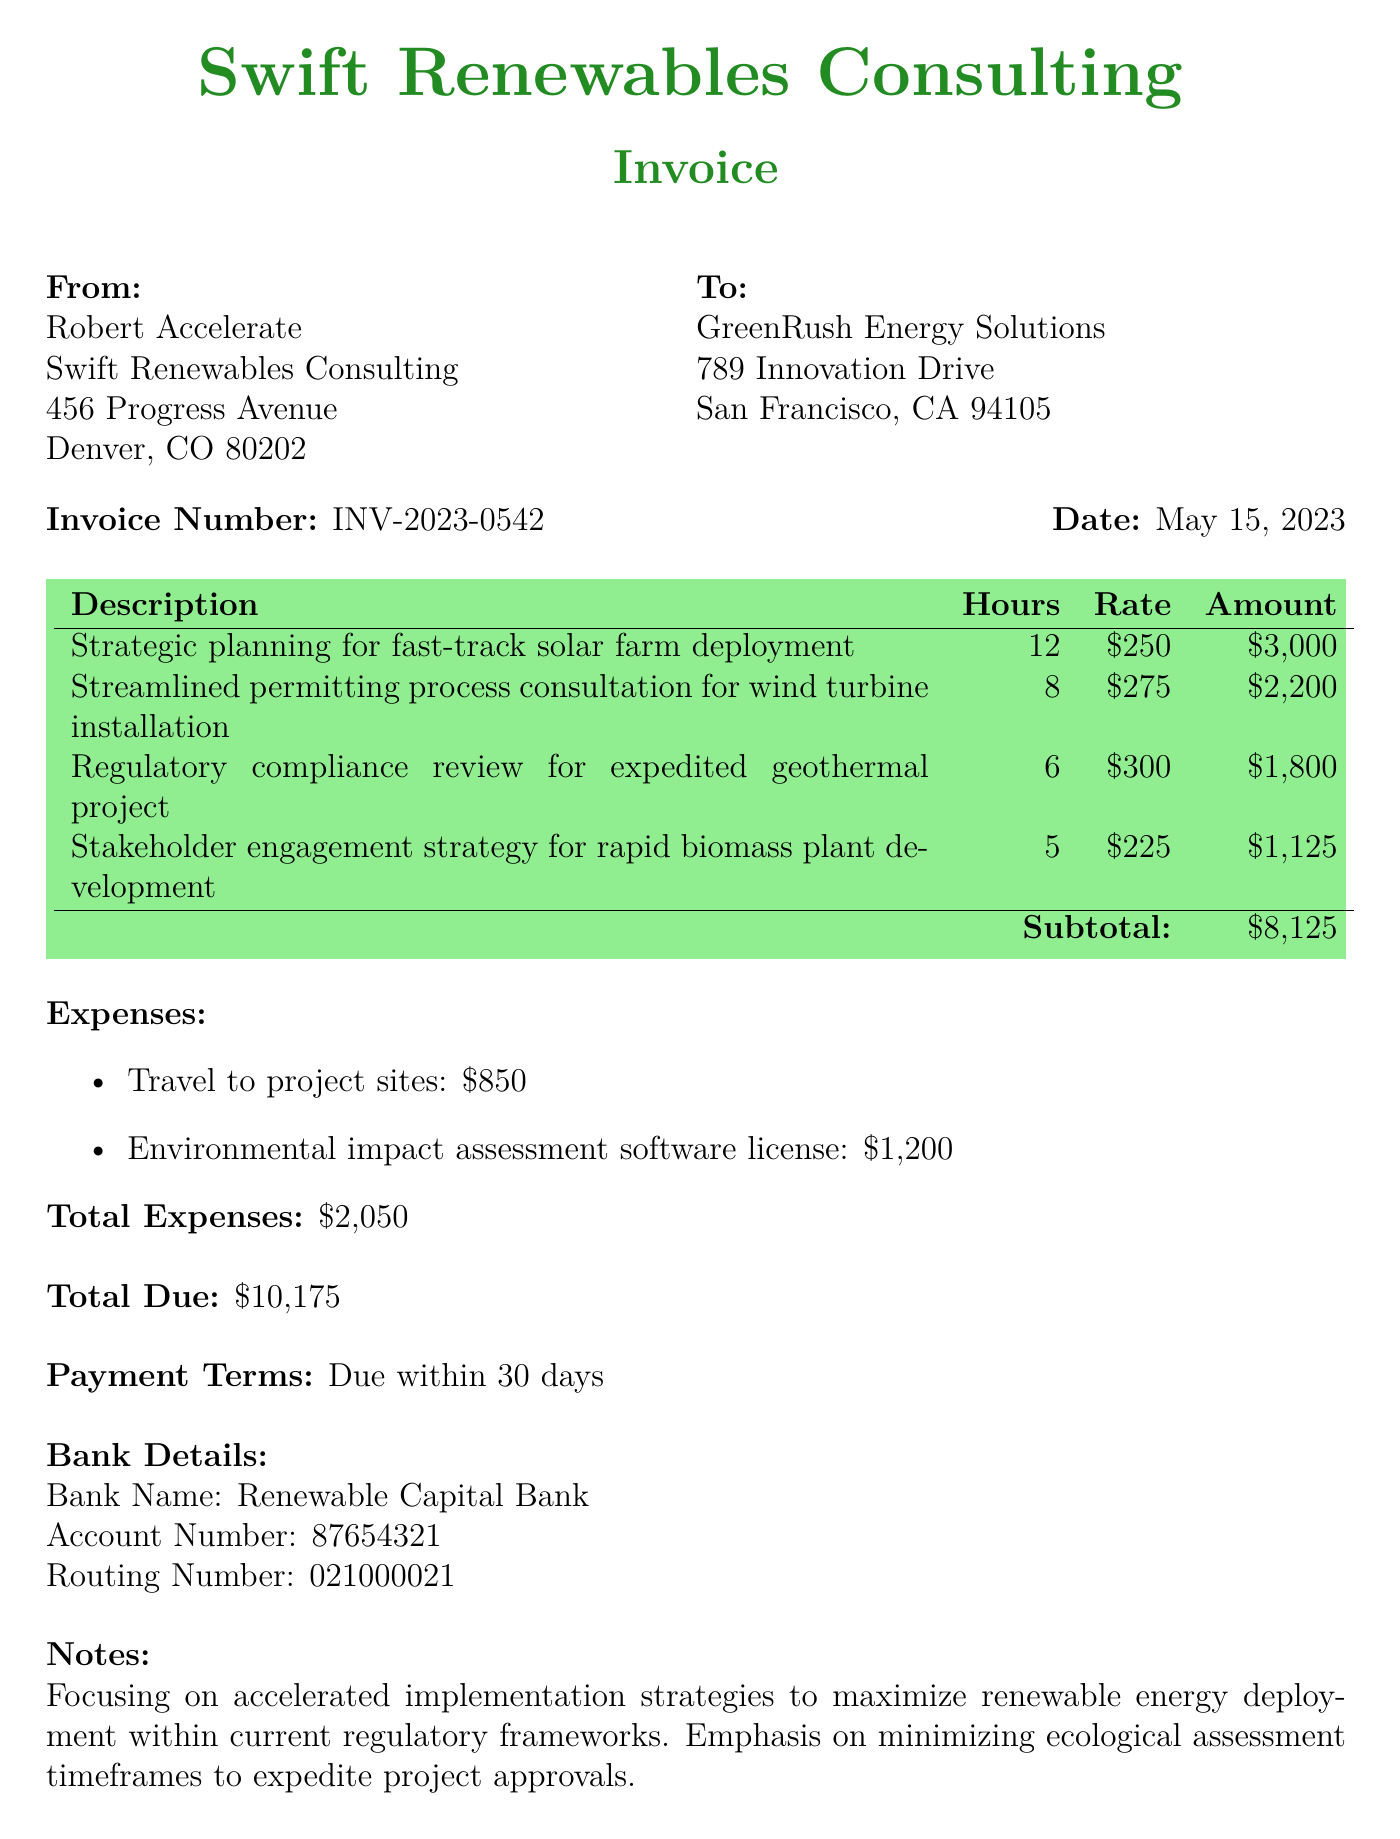What is the invoice number? The invoice number is specifically mentioned in the document as a unique identifier for this invoice.
Answer: INV-2023-0542 Who is the consulting firm? The consulting firm is identified in the document as the entity issuing the invoice.
Answer: Swift Renewables Consulting What is the total due amount? The total due amount is clearly stated as the final payable figure at the end of the invoice.
Answer: $10,175 How many hours were spent on the solar farm deployment planning? The hours spent on this specific service are detailed in the services rendered section of the invoice.
Answer: 12 What is the rate for stakeholder engagement strategy consultation? The rate for this specific service is provided in the table of services rendered.
Answer: $225 What are the total expenses reported? The document sums up all additional expenses related to the project, which is a common aspect of invoices.
Answer: $2,050 What is the payment term for the invoice? The payment term specifies when the payment is expected to be made according to the document.
Answer: Due within 30 days Which project had the highest consulting rate? The consulting rates for various projects are listed, and this requires comparing them to determine the highest.
Answer: Regulatory compliance review for expedited geothermal project What is the travel expense mentioned? The invoice includes specific expenses incurred, one of which pertains to travel costs.
Answer: $850 